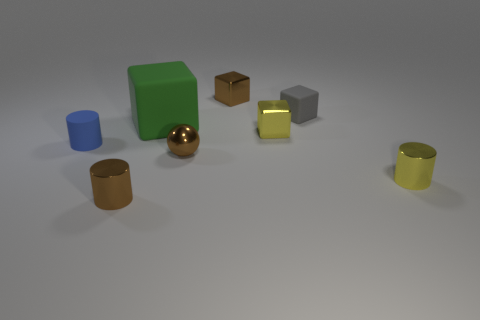What number of objects are things left of the small brown shiny cube or metallic cylinders that are to the right of the yellow metal block?
Give a very brief answer. 5. There is a big object that is to the left of the tiny shiny thing that is behind the large green matte block; what shape is it?
Provide a succinct answer. Cube. Are there any other things of the same color as the small shiny ball?
Keep it short and to the point. Yes. Is there anything else that is the same size as the brown ball?
Ensure brevity in your answer.  Yes. How many objects are either tiny gray spheres or green matte blocks?
Give a very brief answer. 1. Is there a cyan sphere of the same size as the yellow metal cube?
Provide a succinct answer. No. What shape is the green thing?
Keep it short and to the point. Cube. Is the number of cubes in front of the tiny yellow metallic cube greater than the number of tiny gray cubes that are in front of the blue cylinder?
Your answer should be very brief. No. Do the shiny cylinder right of the brown metallic cube and the rubber block in front of the small gray matte block have the same color?
Offer a terse response. No. What is the shape of the gray thing that is the same size as the brown metallic ball?
Ensure brevity in your answer.  Cube. 